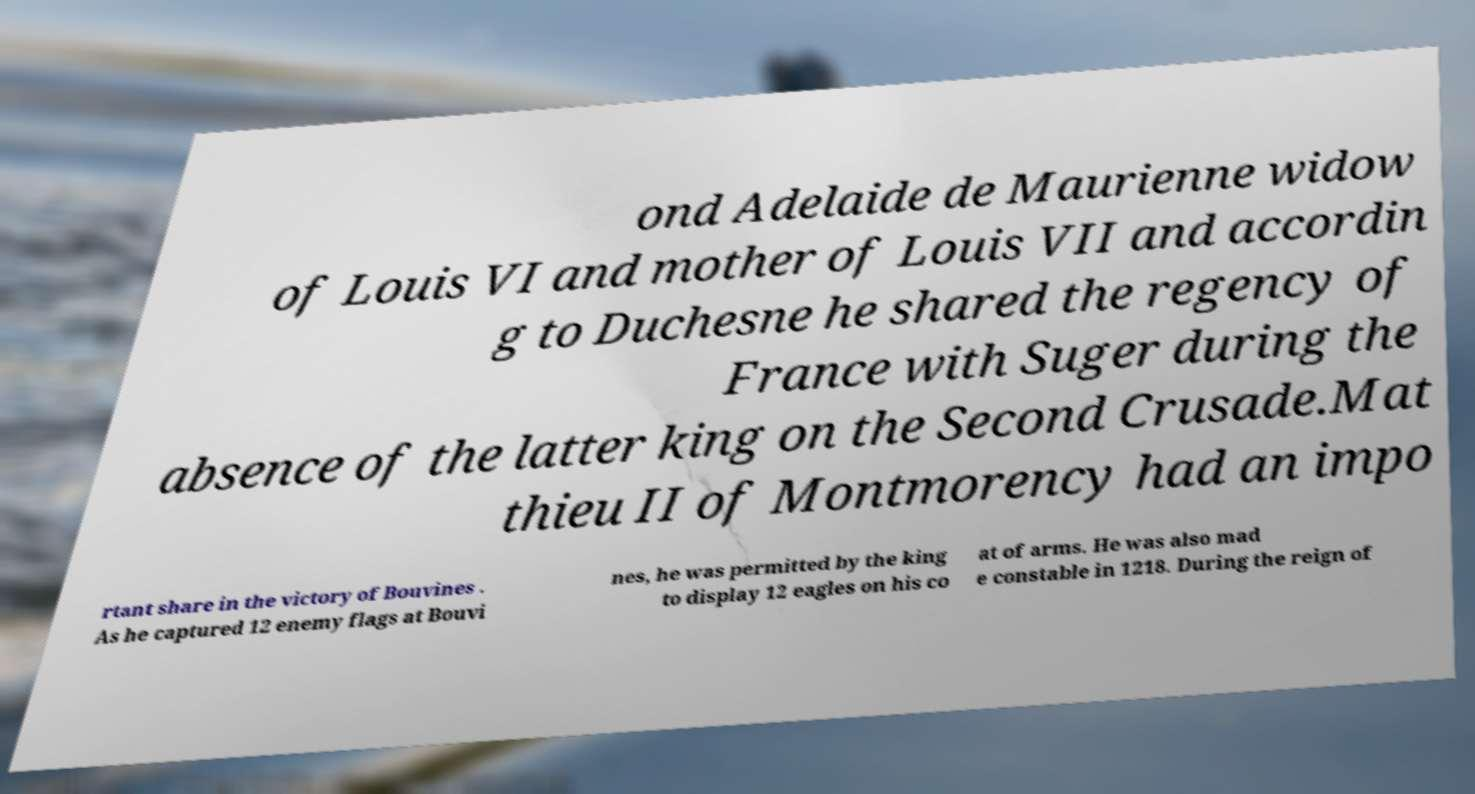Please identify and transcribe the text found in this image. ond Adelaide de Maurienne widow of Louis VI and mother of Louis VII and accordin g to Duchesne he shared the regency of France with Suger during the absence of the latter king on the Second Crusade.Mat thieu II of Montmorency had an impo rtant share in the victory of Bouvines . As he captured 12 enemy flags at Bouvi nes, he was permitted by the king to display 12 eagles on his co at of arms. He was also mad e constable in 1218. During the reign of 